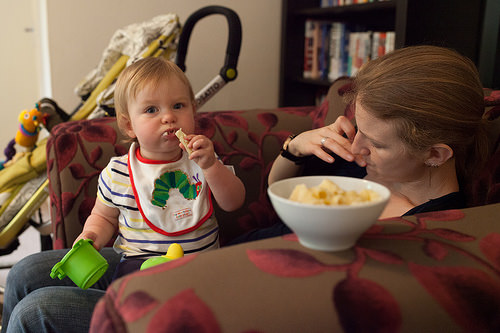<image>
Can you confirm if the baby is on the mother? Yes. Looking at the image, I can see the baby is positioned on top of the mother, with the mother providing support. Is the woman behind the bowl? Yes. From this viewpoint, the woman is positioned behind the bowl, with the bowl partially or fully occluding the woman. 